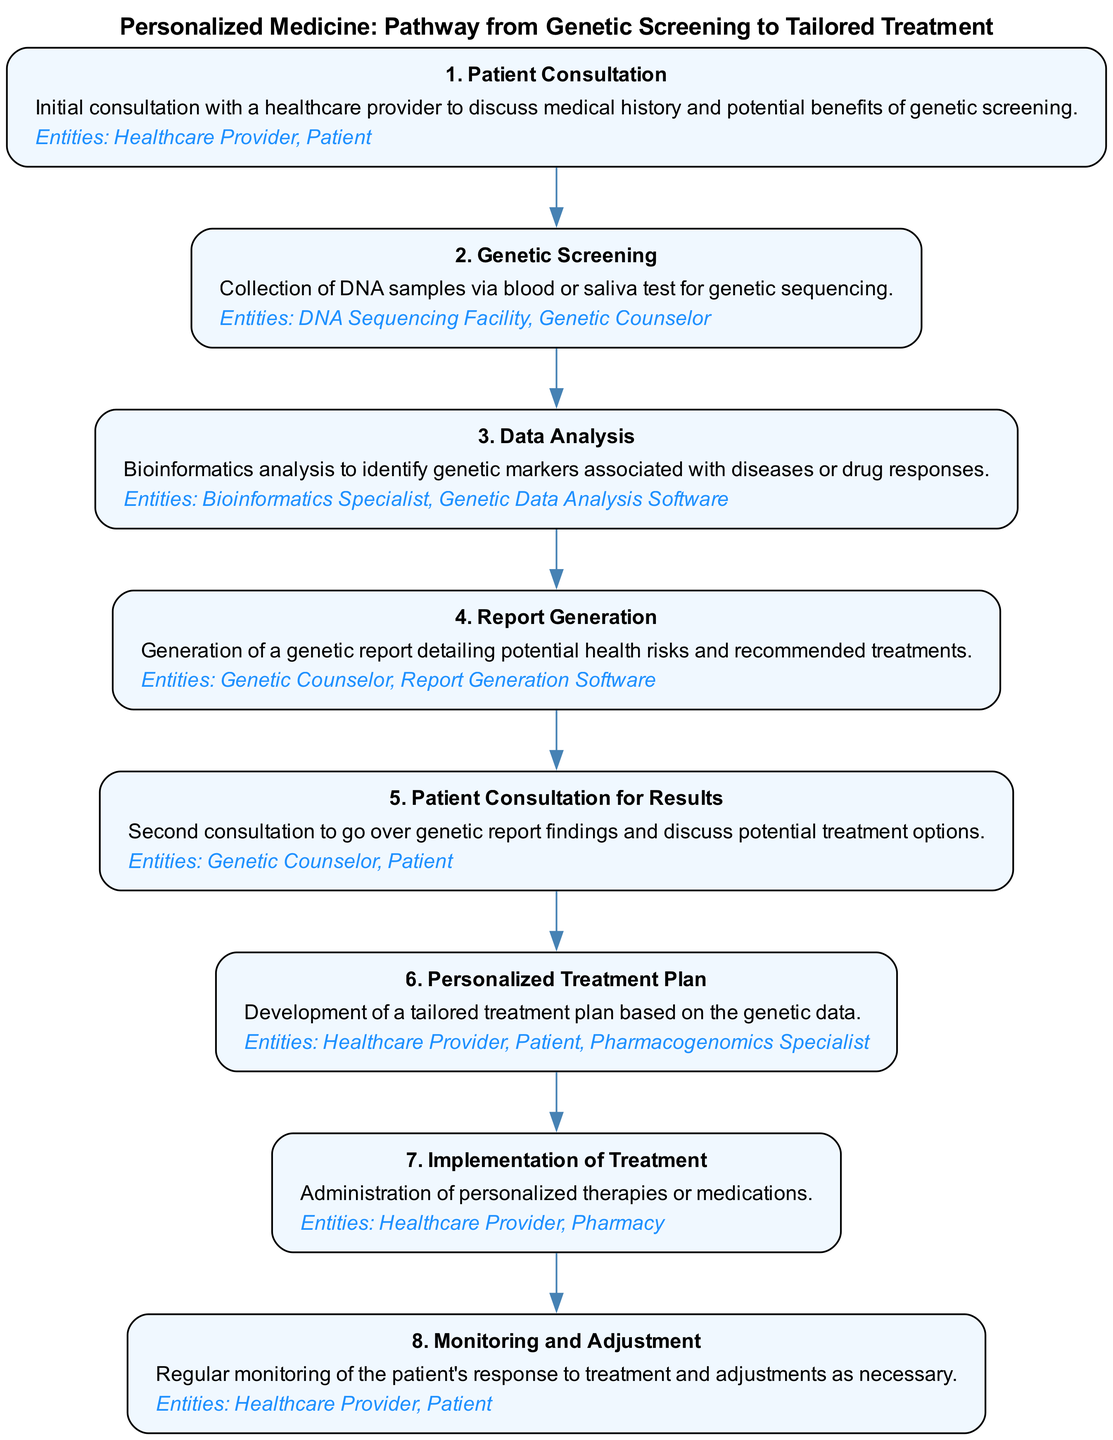What is the title of the clinical pathway? The title can be found at the top of the diagram, which is labeled "Personalized Medicine: Pathway from Genetic Screening to Tailored Treatment."
Answer: Personalized Medicine: Pathway from Genetic Screening to Tailored Treatment How many steps are there in the clinical pathway? By counting the individual steps listed in the diagram, we find there are a total of eight steps.
Answer: 8 What is the first step in the pathway? The first step listed in the diagram is "Patient Consultation," described as the initial consultation with a healthcare provider.
Answer: Patient Consultation Who is involved in the implementation of treatment? The entities listed in the "Implementation of Treatment" step include "Healthcare Provider" and "Pharmacy." Therefore, both entities are involved in this process.
Answer: Healthcare Provider, Pharmacy Which step focuses on monitoring and making adjustments? The diagram indicates that the step titled "Monitoring and Adjustment" emphasizes this aspect after treatment has started.
Answer: Monitoring and Adjustment What type of specialist is involved in developing the personalized treatment plan? The "Personalized Treatment Plan" step mentions the involvement of a "Pharmacogenomics Specialist," indicating that this specialist plays a key role.
Answer: Pharmacogenomics Specialist What is the purpose of the Data Analysis step? According to the description in the diagram, the purpose is to conduct bioinformatics analysis to identify genetic markers associated with diseases or drug responses.
Answer: Identify genetic markers Which step comes after the Report Generation? The flow in the diagram shows that after the "Report Generation," the next step is "Patient Consultation for Results."
Answer: Patient Consultation for Results How does the pathway begin? The pathway begins with patient consultation, where discussions about medical history and genetic screening occur. This sets the stage for the subsequent steps.
Answer: Patient Consultation 